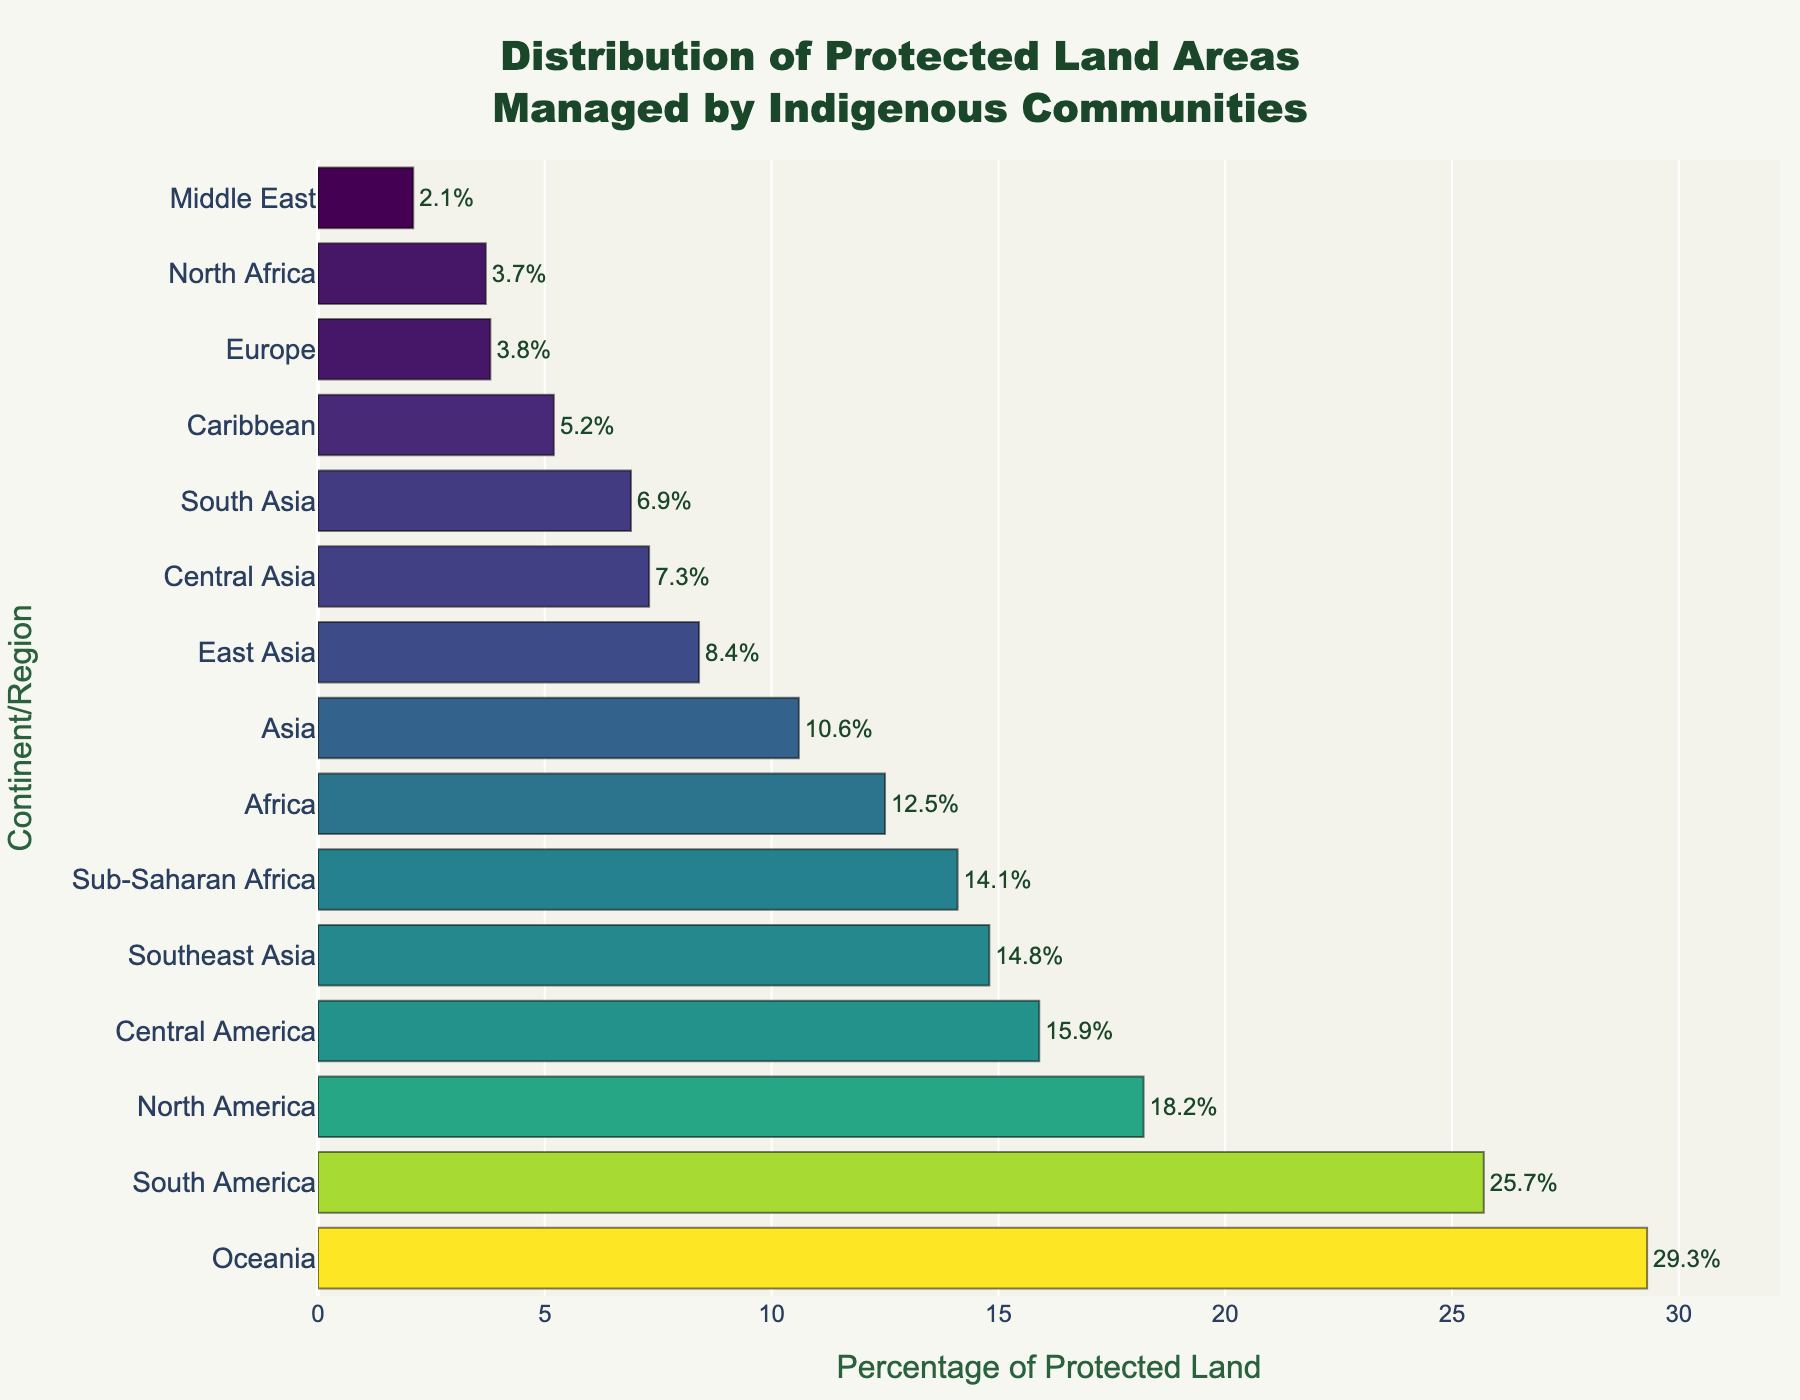Which continent has the highest percentage of protected land managed by indigenous communities? By observing the bar lengths, Oceania has the longest bar, indicating the highest percentage.
Answer: Oceania Which continents have a lower percentage of protected land managed by indigenous communities compared to Africa (12.5%)? By comparing the bar lengths, Europe, Caribbean, Middle East, Central Asia, South Asia, East Asia, and North Africa have shorter bars than Africa.
Answer: Europe, Caribbean, Middle East, Central Asia, South Asia, East Asia, North Africa What is the combined percentage of protected land managed by indigenous communities in North America and South America? By adding the percentages, (18.2 + 25.7) = 43.9.
Answer: 43.9 Which region has a higher percentage of protected land managed by indigenous communities, Central America or Southeast Asia? By comparing the bar lengths, Southeast Asia has a slightly longer bar than Central America.
Answer: Southeast Asia What is the difference in the percentage of protected land managed by indigenous communities between Oceania and Asia? By subtracting the percentages, (29.3 - 10.6) = 18.7.
Answer: 18.7 Approximately what is the average percentage of protected land managed by indigenous communities in South America, Central America, and Sub-Saharan Africa? Adding the percentages and dividing by 3, (25.7 + 15.9 + 14.1) / 3 = 18.57.
Answer: 18.57 Which region has a closer percentage of protected land managed by indigenous communities to North Africa (3.7) - Europe or Caribbean? By comparing the bars, Europe (3.8) is closer to North Africa (3.7) than Caribbean (5.2).
Answer: Europe Which two regions have the most similar percentages of protected land managed by indigenous communities? By comparing the bars, North Africa (3.7) and Europe (3.8) have almost identical lengths.
Answer: North Africa and Europe 